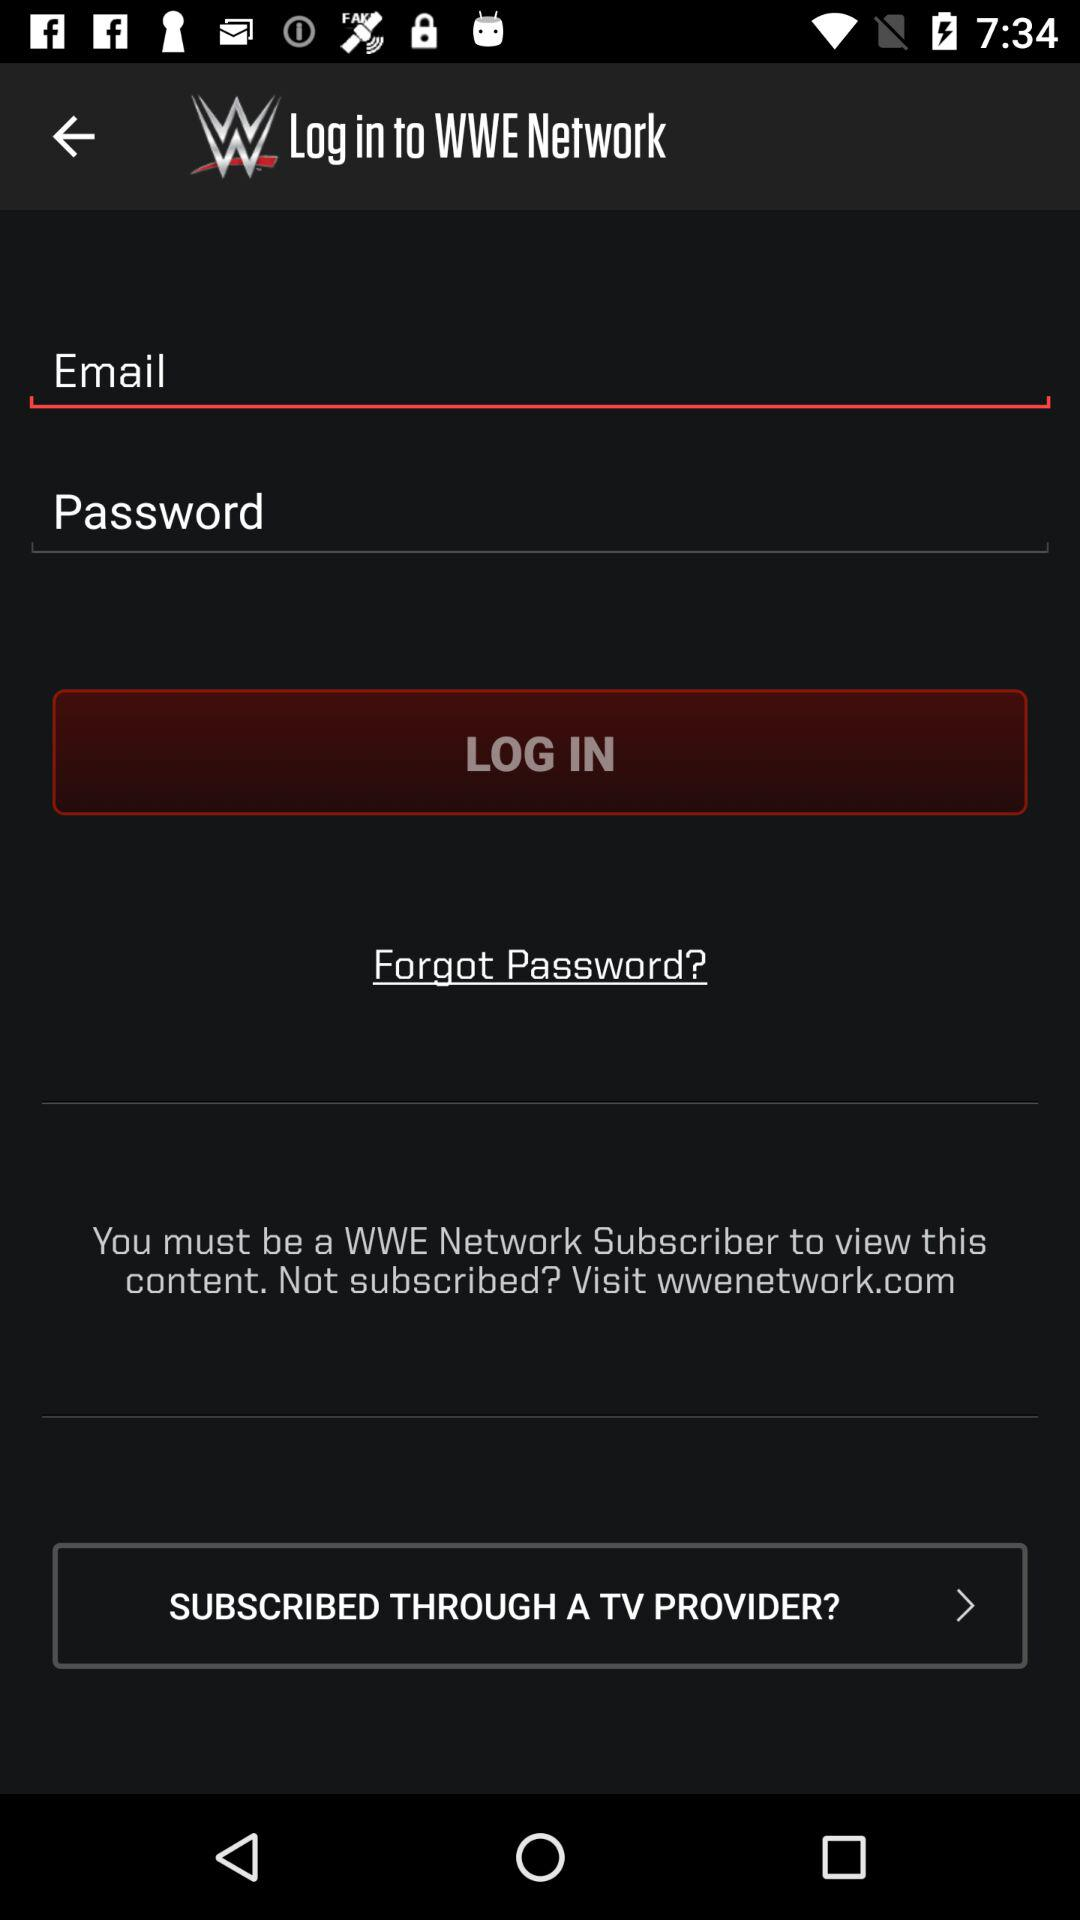What is the application name? The application name is "WWE Network". 